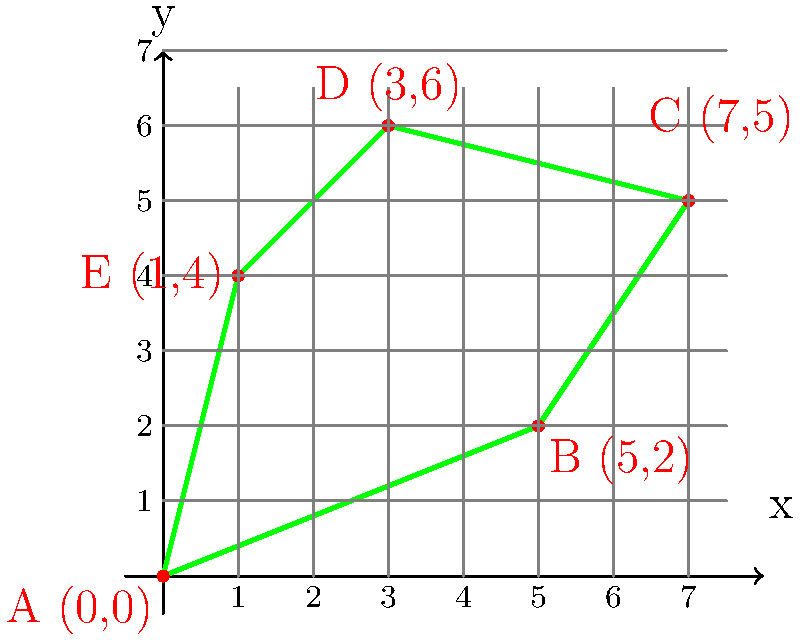A sustainable cannabis cultivation area is represented by the irregular pentagon ABCDE on the coordinate plane, where A(0,0), B(5,2), C(7,5), D(3,6), and E(1,4) are the vertices. Calculate the perimeter of this cultivation area to determine the amount of eco-friendly fencing needed. Round your answer to two decimal places. To find the perimeter of the irregular pentagon, we need to calculate the distance between each pair of consecutive points and sum them up. We'll use the distance formula: $d = \sqrt{(x_2-x_1)^2 + (y_2-y_1)^2}$

1. Distance AB:
   $d_{AB} = \sqrt{(5-0)^2 + (2-0)^2} = \sqrt{25 + 4} = \sqrt{29}$

2. Distance BC:
   $d_{BC} = \sqrt{(7-5)^2 + (5-2)^2} = \sqrt{4 + 9} = \sqrt{13}$

3. Distance CD:
   $d_{CD} = \sqrt{(3-7)^2 + (6-5)^2} = \sqrt{16 + 1} = \sqrt{17}$

4. Distance DE:
   $d_{DE} = \sqrt{(1-3)^2 + (4-6)^2} = \sqrt{4 + 4} = \sqrt{8} = 2\sqrt{2}$

5. Distance EA:
   $d_{EA} = \sqrt{(0-1)^2 + (0-4)^2} = \sqrt{1 + 16} = \sqrt{17}$

Sum up all distances:
$\text{Perimeter} = \sqrt{29} + \sqrt{13} + \sqrt{17} + 2\sqrt{2} + \sqrt{17}$

Simplify:
$\text{Perimeter} = \sqrt{29} + \sqrt{13} + 2\sqrt{17} + 2\sqrt{2}$

Using a calculator and rounding to two decimal places:
$\text{Perimeter} \approx 5.39 + 3.61 + 8.25 + 2.83 = 20.08$
Answer: 20.08 units 